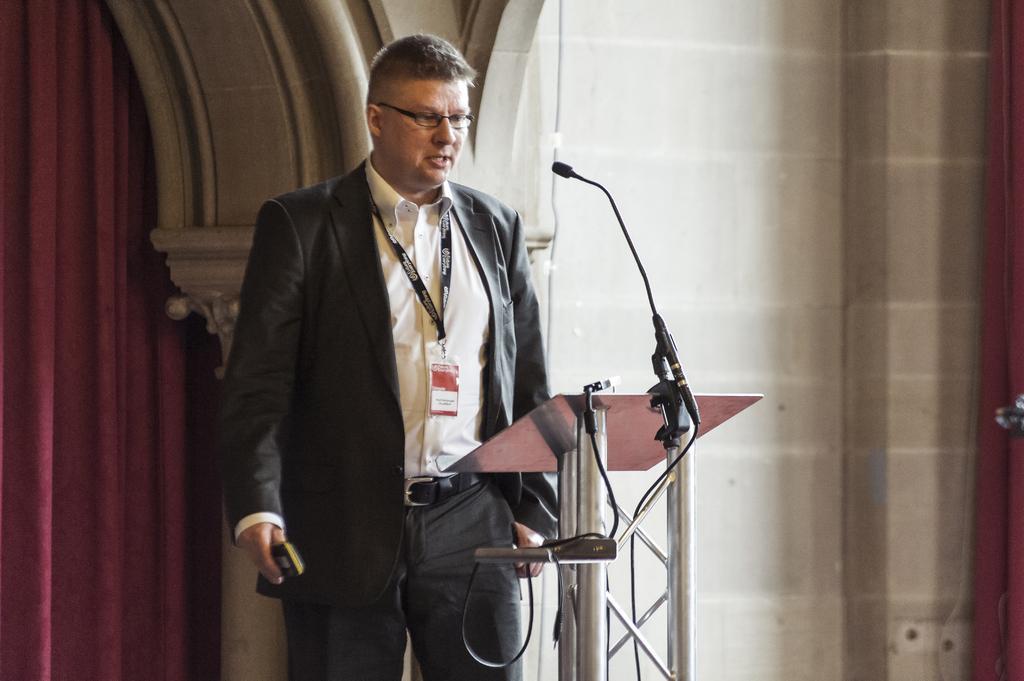Please provide a concise description of this image. In this picture there is a man in the front, wearing black suit, standing in the front of the metal pipe speech desk. Behind there is a brick wall and red curtain. 